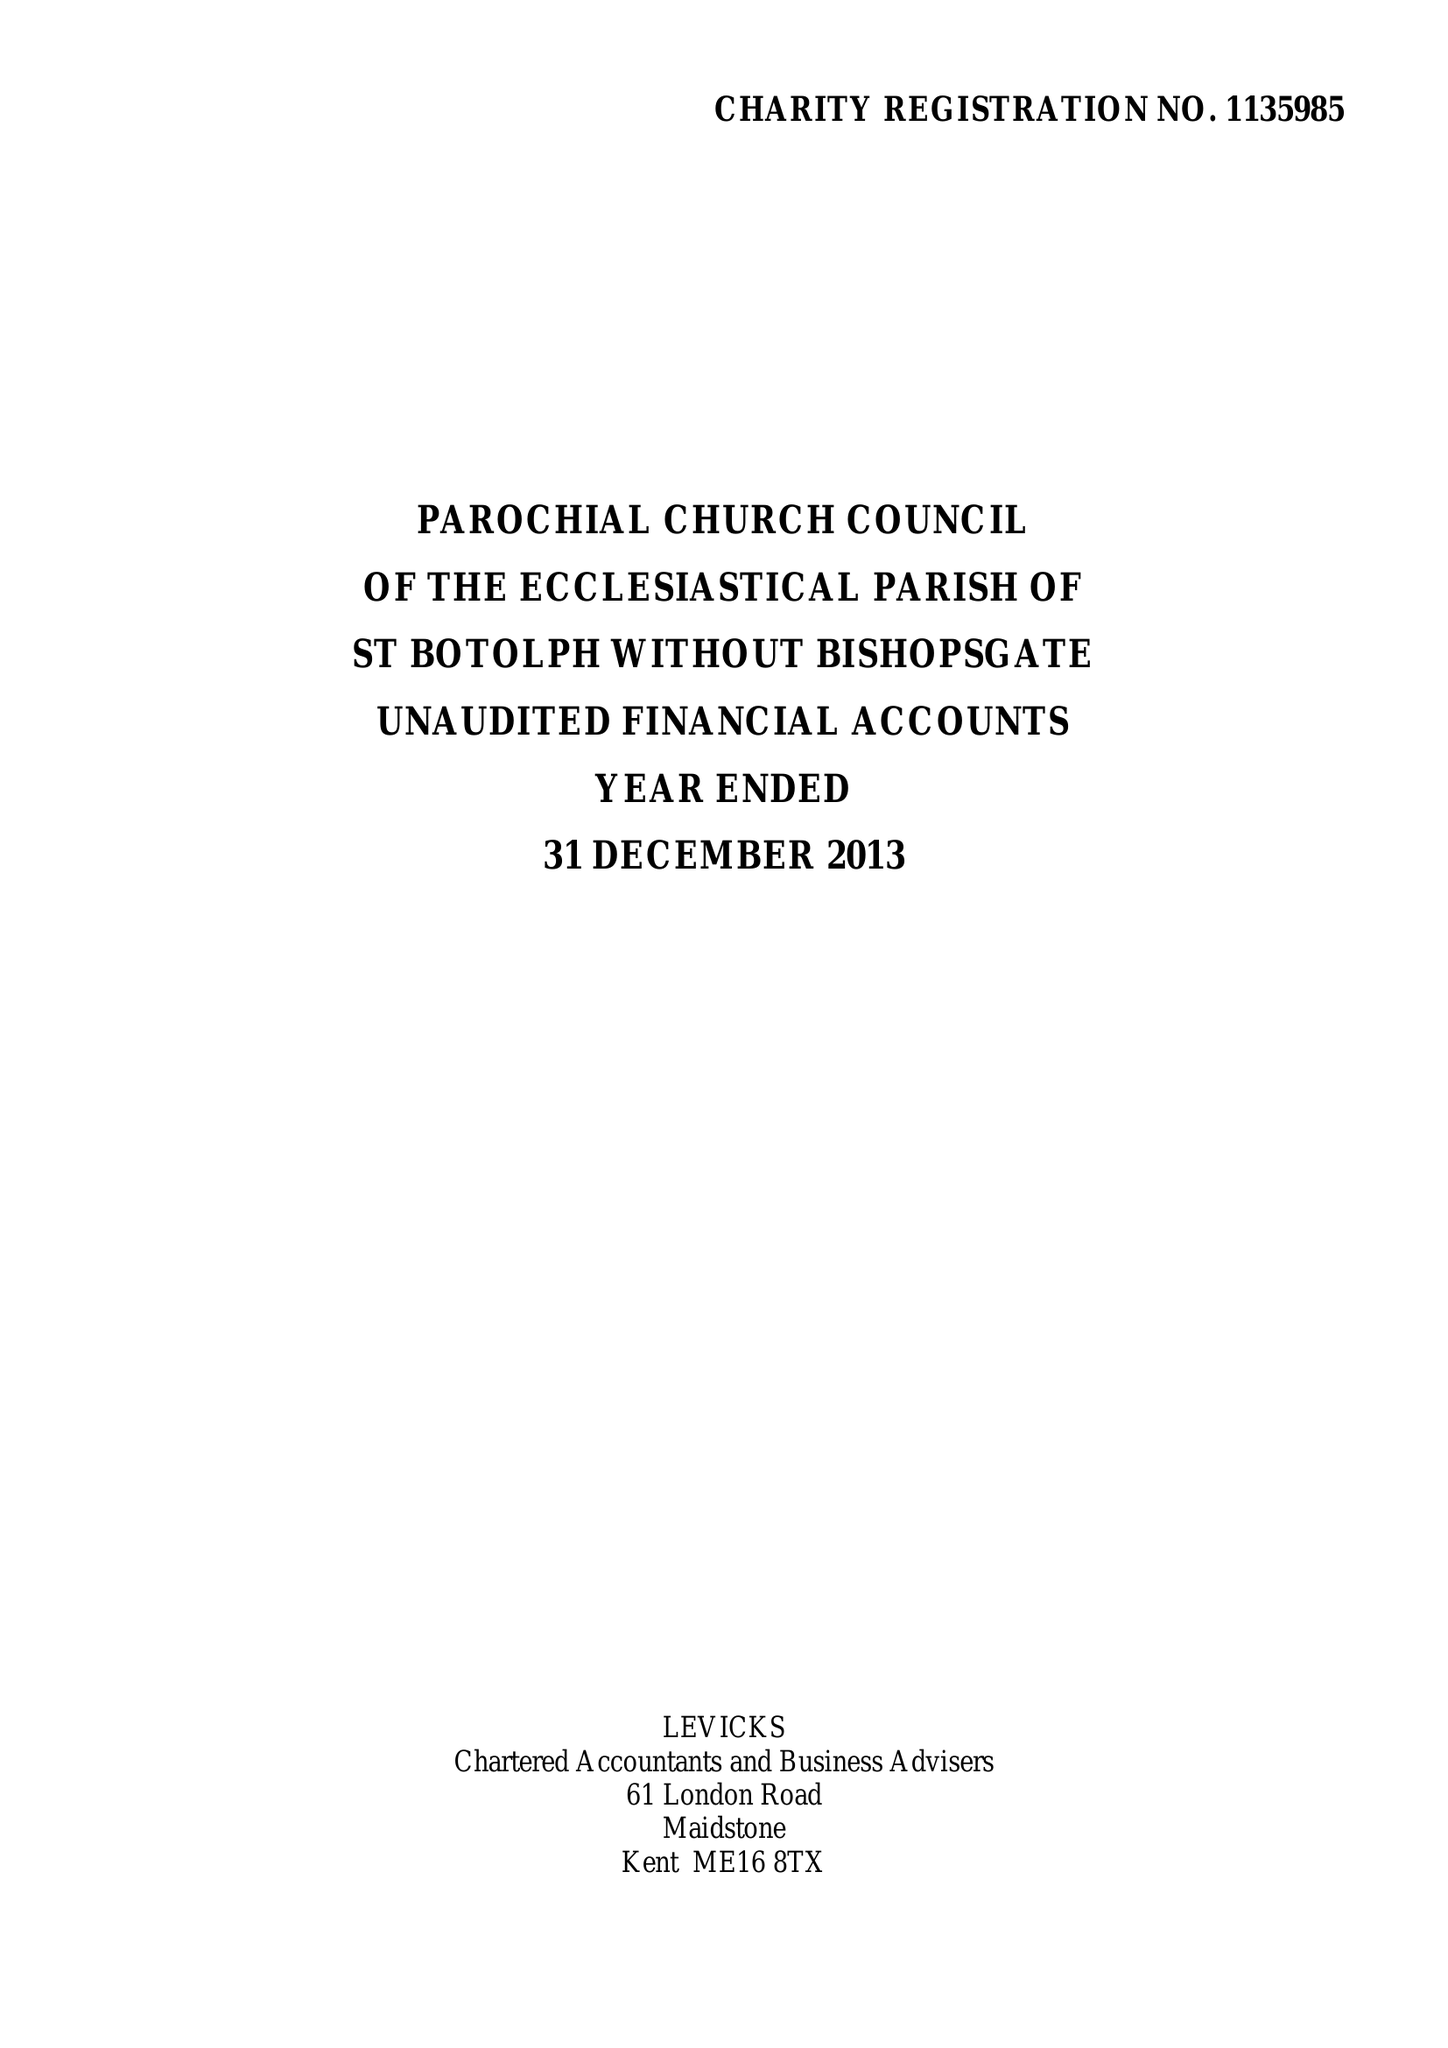What is the value for the income_annually_in_british_pounds?
Answer the question using a single word or phrase. 313180.00 